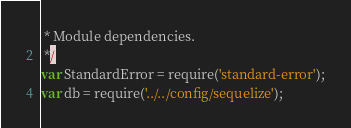<code> <loc_0><loc_0><loc_500><loc_500><_JavaScript_> * Module dependencies.
 */
var StandardError = require('standard-error');
var db = require('../../config/sequelize');</code> 